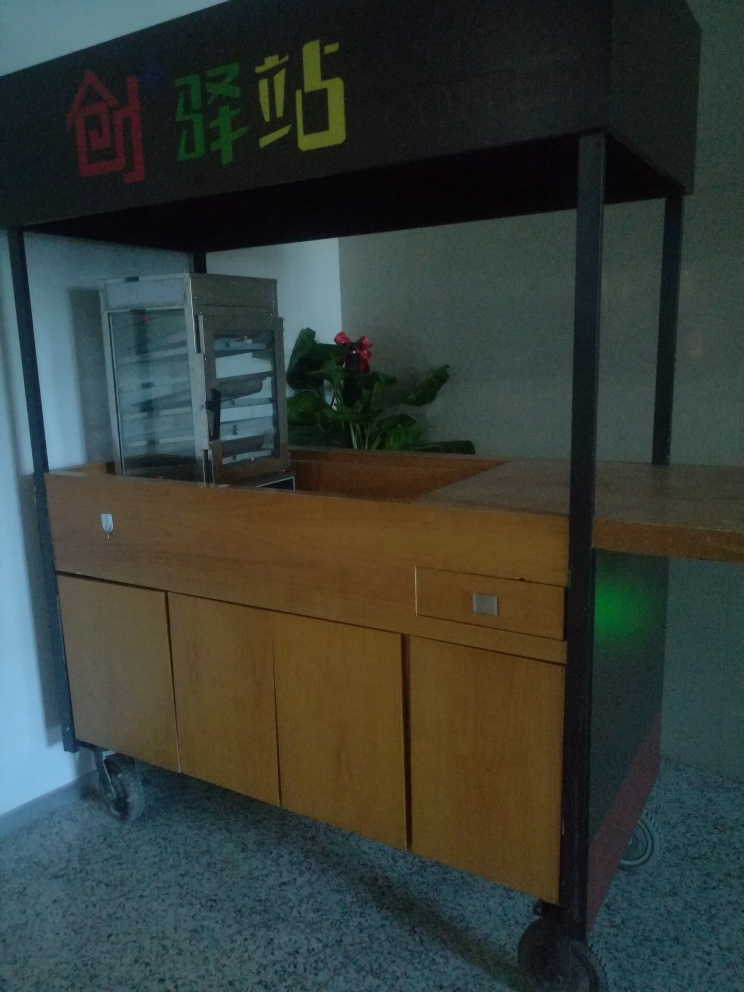Is there anything in the image that indicates the cultural or geographic context? While it's challenging to pinpoint the exact cultural or geographic location from this image alone, the characters on the signage suggest the location might be in a Chinese-speaking region. The design of the furniture and the cabinet's simplicity could hint at a utilitarian, possibly East Asian aesthetic. 